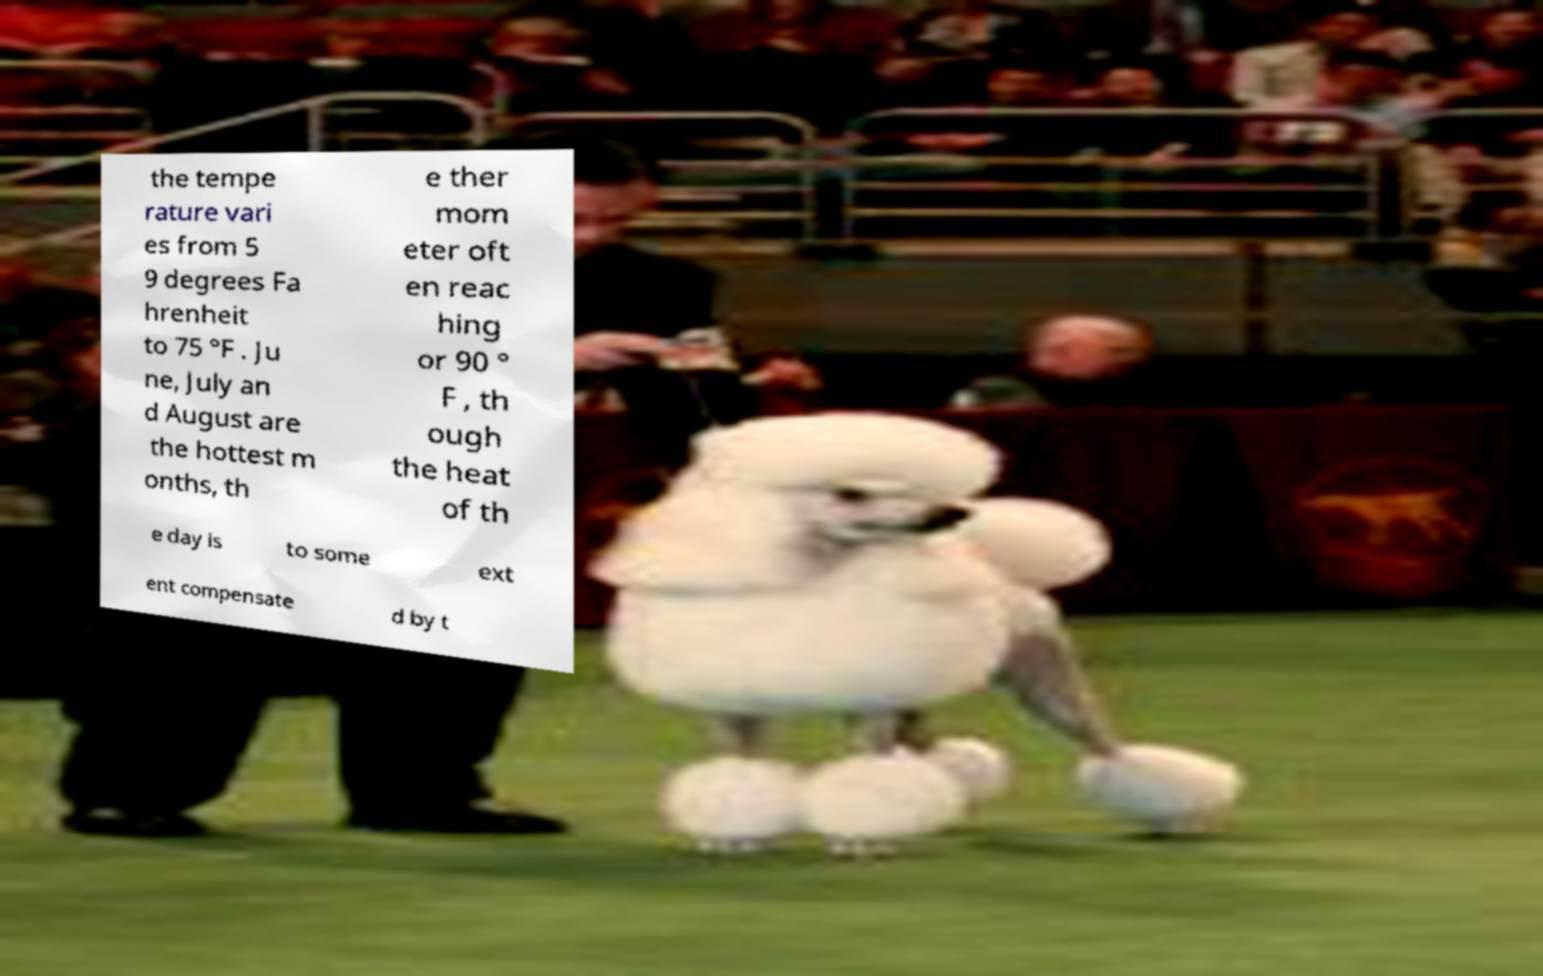I need the written content from this picture converted into text. Can you do that? the tempe rature vari es from 5 9 degrees Fa hrenheit to 75 °F . Ju ne, July an d August are the hottest m onths, th e ther mom eter oft en reac hing or 90 ° F , th ough the heat of th e day is to some ext ent compensate d by t 